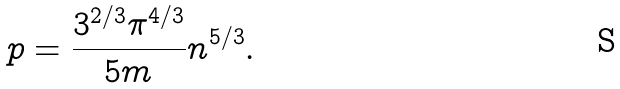<formula> <loc_0><loc_0><loc_500><loc_500>p = \frac { 3 ^ { 2 / 3 } \pi ^ { 4 / 3 } } { 5 m } n ^ { 5 / 3 } .</formula> 